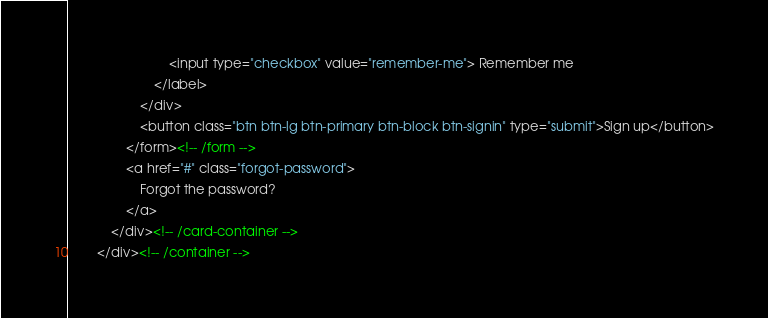Convert code to text. <code><loc_0><loc_0><loc_500><loc_500><_HTML_>                            <input type="checkbox" value="remember-me"> Remember me
                        </label>
                    </div>
                    <button class="btn btn-lg btn-primary btn-block btn-signin" type="submit">Sign up</button>
                </form><!-- /form -->
                <a href="#" class="forgot-password">
                    Forgot the password?
                </a>
            </div><!-- /card-container -->
        </div><!-- /container --></code> 